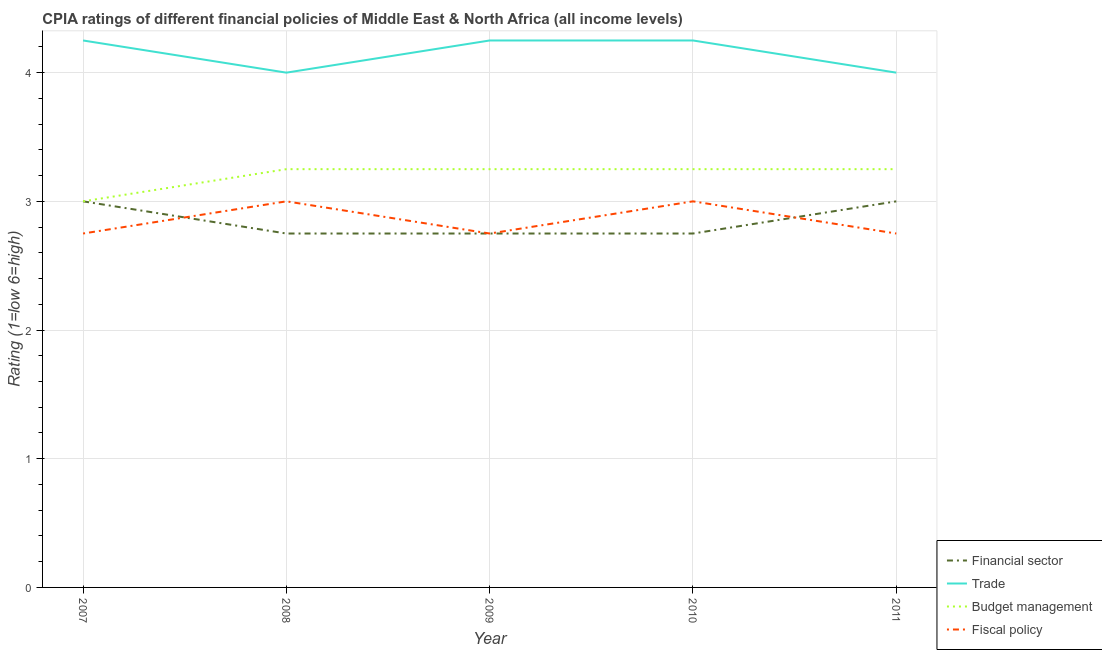How many different coloured lines are there?
Offer a terse response. 4. Is the number of lines equal to the number of legend labels?
Keep it short and to the point. Yes. What is the cpia rating of financial sector in 2011?
Keep it short and to the point. 3. Across all years, what is the maximum cpia rating of trade?
Offer a terse response. 4.25. What is the total cpia rating of financial sector in the graph?
Keep it short and to the point. 14.25. What is the average cpia rating of financial sector per year?
Ensure brevity in your answer.  2.85. In the year 2008, what is the difference between the cpia rating of fiscal policy and cpia rating of financial sector?
Your response must be concise. 0.25. What is the ratio of the cpia rating of fiscal policy in 2008 to that in 2010?
Keep it short and to the point. 1. Is the difference between the cpia rating of budget management in 2009 and 2011 greater than the difference between the cpia rating of trade in 2009 and 2011?
Give a very brief answer. No. In how many years, is the cpia rating of financial sector greater than the average cpia rating of financial sector taken over all years?
Give a very brief answer. 2. Is it the case that in every year, the sum of the cpia rating of financial sector and cpia rating of trade is greater than the cpia rating of budget management?
Give a very brief answer. Yes. Does the cpia rating of budget management monotonically increase over the years?
Provide a short and direct response. No. Is the cpia rating of trade strictly greater than the cpia rating of fiscal policy over the years?
Offer a very short reply. Yes. Does the graph contain any zero values?
Your response must be concise. No. Does the graph contain grids?
Your answer should be compact. Yes. Where does the legend appear in the graph?
Provide a short and direct response. Bottom right. How many legend labels are there?
Offer a terse response. 4. How are the legend labels stacked?
Your response must be concise. Vertical. What is the title of the graph?
Offer a terse response. CPIA ratings of different financial policies of Middle East & North Africa (all income levels). What is the label or title of the Y-axis?
Offer a terse response. Rating (1=low 6=high). What is the Rating (1=low 6=high) of Trade in 2007?
Provide a succinct answer. 4.25. What is the Rating (1=low 6=high) in Budget management in 2007?
Offer a terse response. 3. What is the Rating (1=low 6=high) in Fiscal policy in 2007?
Your answer should be compact. 2.75. What is the Rating (1=low 6=high) in Financial sector in 2008?
Give a very brief answer. 2.75. What is the Rating (1=low 6=high) of Financial sector in 2009?
Keep it short and to the point. 2.75. What is the Rating (1=low 6=high) of Trade in 2009?
Provide a short and direct response. 4.25. What is the Rating (1=low 6=high) in Fiscal policy in 2009?
Provide a succinct answer. 2.75. What is the Rating (1=low 6=high) of Financial sector in 2010?
Provide a short and direct response. 2.75. What is the Rating (1=low 6=high) in Trade in 2010?
Offer a terse response. 4.25. What is the Rating (1=low 6=high) of Financial sector in 2011?
Keep it short and to the point. 3. What is the Rating (1=low 6=high) of Trade in 2011?
Keep it short and to the point. 4. What is the Rating (1=low 6=high) in Fiscal policy in 2011?
Ensure brevity in your answer.  2.75. Across all years, what is the maximum Rating (1=low 6=high) in Trade?
Your answer should be compact. 4.25. Across all years, what is the maximum Rating (1=low 6=high) in Budget management?
Provide a short and direct response. 3.25. Across all years, what is the maximum Rating (1=low 6=high) of Fiscal policy?
Give a very brief answer. 3. Across all years, what is the minimum Rating (1=low 6=high) in Financial sector?
Offer a terse response. 2.75. Across all years, what is the minimum Rating (1=low 6=high) in Trade?
Your answer should be very brief. 4. Across all years, what is the minimum Rating (1=low 6=high) in Budget management?
Make the answer very short. 3. Across all years, what is the minimum Rating (1=low 6=high) of Fiscal policy?
Your response must be concise. 2.75. What is the total Rating (1=low 6=high) in Financial sector in the graph?
Your answer should be very brief. 14.25. What is the total Rating (1=low 6=high) in Trade in the graph?
Your answer should be compact. 20.75. What is the total Rating (1=low 6=high) in Budget management in the graph?
Provide a short and direct response. 16. What is the total Rating (1=low 6=high) of Fiscal policy in the graph?
Provide a succinct answer. 14.25. What is the difference between the Rating (1=low 6=high) of Budget management in 2007 and that in 2008?
Your response must be concise. -0.25. What is the difference between the Rating (1=low 6=high) in Fiscal policy in 2007 and that in 2008?
Offer a very short reply. -0.25. What is the difference between the Rating (1=low 6=high) in Trade in 2007 and that in 2009?
Your answer should be compact. 0. What is the difference between the Rating (1=low 6=high) in Budget management in 2007 and that in 2009?
Your response must be concise. -0.25. What is the difference between the Rating (1=low 6=high) of Budget management in 2007 and that in 2010?
Your answer should be very brief. -0.25. What is the difference between the Rating (1=low 6=high) of Financial sector in 2007 and that in 2011?
Make the answer very short. 0. What is the difference between the Rating (1=low 6=high) of Trade in 2007 and that in 2011?
Give a very brief answer. 0.25. What is the difference between the Rating (1=low 6=high) of Budget management in 2007 and that in 2011?
Give a very brief answer. -0.25. What is the difference between the Rating (1=low 6=high) of Fiscal policy in 2007 and that in 2011?
Your answer should be compact. 0. What is the difference between the Rating (1=low 6=high) of Financial sector in 2008 and that in 2009?
Your response must be concise. 0. What is the difference between the Rating (1=low 6=high) of Fiscal policy in 2008 and that in 2009?
Provide a short and direct response. 0.25. What is the difference between the Rating (1=low 6=high) of Financial sector in 2009 and that in 2010?
Keep it short and to the point. 0. What is the difference between the Rating (1=low 6=high) in Trade in 2009 and that in 2010?
Offer a very short reply. 0. What is the difference between the Rating (1=low 6=high) of Fiscal policy in 2009 and that in 2010?
Provide a succinct answer. -0.25. What is the difference between the Rating (1=low 6=high) in Trade in 2009 and that in 2011?
Offer a very short reply. 0.25. What is the difference between the Rating (1=low 6=high) in Budget management in 2009 and that in 2011?
Your response must be concise. 0. What is the difference between the Rating (1=low 6=high) in Fiscal policy in 2009 and that in 2011?
Your response must be concise. 0. What is the difference between the Rating (1=low 6=high) of Fiscal policy in 2010 and that in 2011?
Offer a terse response. 0.25. What is the difference between the Rating (1=low 6=high) of Financial sector in 2007 and the Rating (1=low 6=high) of Budget management in 2008?
Give a very brief answer. -0.25. What is the difference between the Rating (1=low 6=high) of Financial sector in 2007 and the Rating (1=low 6=high) of Fiscal policy in 2008?
Your response must be concise. 0. What is the difference between the Rating (1=low 6=high) of Financial sector in 2007 and the Rating (1=low 6=high) of Trade in 2009?
Your answer should be very brief. -1.25. What is the difference between the Rating (1=low 6=high) in Financial sector in 2007 and the Rating (1=low 6=high) in Budget management in 2009?
Make the answer very short. -0.25. What is the difference between the Rating (1=low 6=high) of Trade in 2007 and the Rating (1=low 6=high) of Fiscal policy in 2009?
Your response must be concise. 1.5. What is the difference between the Rating (1=low 6=high) in Budget management in 2007 and the Rating (1=low 6=high) in Fiscal policy in 2009?
Your response must be concise. 0.25. What is the difference between the Rating (1=low 6=high) of Financial sector in 2007 and the Rating (1=low 6=high) of Trade in 2010?
Make the answer very short. -1.25. What is the difference between the Rating (1=low 6=high) in Financial sector in 2007 and the Rating (1=low 6=high) in Fiscal policy in 2010?
Your response must be concise. 0. What is the difference between the Rating (1=low 6=high) in Trade in 2007 and the Rating (1=low 6=high) in Budget management in 2010?
Give a very brief answer. 1. What is the difference between the Rating (1=low 6=high) in Financial sector in 2007 and the Rating (1=low 6=high) in Budget management in 2011?
Make the answer very short. -0.25. What is the difference between the Rating (1=low 6=high) of Financial sector in 2007 and the Rating (1=low 6=high) of Fiscal policy in 2011?
Provide a succinct answer. 0.25. What is the difference between the Rating (1=low 6=high) of Trade in 2007 and the Rating (1=low 6=high) of Fiscal policy in 2011?
Give a very brief answer. 1.5. What is the difference between the Rating (1=low 6=high) of Financial sector in 2008 and the Rating (1=low 6=high) of Trade in 2009?
Your answer should be compact. -1.5. What is the difference between the Rating (1=low 6=high) of Financial sector in 2008 and the Rating (1=low 6=high) of Fiscal policy in 2009?
Ensure brevity in your answer.  0. What is the difference between the Rating (1=low 6=high) in Trade in 2008 and the Rating (1=low 6=high) in Fiscal policy in 2009?
Offer a terse response. 1.25. What is the difference between the Rating (1=low 6=high) in Financial sector in 2008 and the Rating (1=low 6=high) in Fiscal policy in 2010?
Your answer should be compact. -0.25. What is the difference between the Rating (1=low 6=high) of Trade in 2008 and the Rating (1=low 6=high) of Fiscal policy in 2010?
Provide a succinct answer. 1. What is the difference between the Rating (1=low 6=high) in Budget management in 2008 and the Rating (1=low 6=high) in Fiscal policy in 2010?
Offer a terse response. 0.25. What is the difference between the Rating (1=low 6=high) in Financial sector in 2008 and the Rating (1=low 6=high) in Trade in 2011?
Give a very brief answer. -1.25. What is the difference between the Rating (1=low 6=high) in Trade in 2008 and the Rating (1=low 6=high) in Fiscal policy in 2011?
Offer a terse response. 1.25. What is the difference between the Rating (1=low 6=high) of Budget management in 2008 and the Rating (1=low 6=high) of Fiscal policy in 2011?
Give a very brief answer. 0.5. What is the difference between the Rating (1=low 6=high) of Financial sector in 2009 and the Rating (1=low 6=high) of Budget management in 2010?
Give a very brief answer. -0.5. What is the difference between the Rating (1=low 6=high) of Financial sector in 2009 and the Rating (1=low 6=high) of Fiscal policy in 2010?
Offer a terse response. -0.25. What is the difference between the Rating (1=low 6=high) in Trade in 2009 and the Rating (1=low 6=high) in Fiscal policy in 2010?
Your answer should be very brief. 1.25. What is the difference between the Rating (1=low 6=high) of Financial sector in 2009 and the Rating (1=low 6=high) of Trade in 2011?
Give a very brief answer. -1.25. What is the difference between the Rating (1=low 6=high) in Financial sector in 2009 and the Rating (1=low 6=high) in Budget management in 2011?
Ensure brevity in your answer.  -0.5. What is the difference between the Rating (1=low 6=high) of Trade in 2009 and the Rating (1=low 6=high) of Budget management in 2011?
Your response must be concise. 1. What is the difference between the Rating (1=low 6=high) in Trade in 2009 and the Rating (1=low 6=high) in Fiscal policy in 2011?
Offer a terse response. 1.5. What is the difference between the Rating (1=low 6=high) of Budget management in 2009 and the Rating (1=low 6=high) of Fiscal policy in 2011?
Your response must be concise. 0.5. What is the difference between the Rating (1=low 6=high) of Financial sector in 2010 and the Rating (1=low 6=high) of Trade in 2011?
Make the answer very short. -1.25. What is the difference between the Rating (1=low 6=high) of Financial sector in 2010 and the Rating (1=low 6=high) of Fiscal policy in 2011?
Offer a terse response. 0. What is the difference between the Rating (1=low 6=high) of Trade in 2010 and the Rating (1=low 6=high) of Budget management in 2011?
Provide a succinct answer. 1. What is the average Rating (1=low 6=high) in Financial sector per year?
Your answer should be compact. 2.85. What is the average Rating (1=low 6=high) in Trade per year?
Your answer should be compact. 4.15. What is the average Rating (1=low 6=high) of Budget management per year?
Make the answer very short. 3.2. What is the average Rating (1=low 6=high) in Fiscal policy per year?
Provide a short and direct response. 2.85. In the year 2007, what is the difference between the Rating (1=low 6=high) in Financial sector and Rating (1=low 6=high) in Trade?
Your response must be concise. -1.25. In the year 2007, what is the difference between the Rating (1=low 6=high) of Trade and Rating (1=low 6=high) of Budget management?
Ensure brevity in your answer.  1.25. In the year 2007, what is the difference between the Rating (1=low 6=high) in Trade and Rating (1=low 6=high) in Fiscal policy?
Ensure brevity in your answer.  1.5. In the year 2008, what is the difference between the Rating (1=low 6=high) of Financial sector and Rating (1=low 6=high) of Trade?
Make the answer very short. -1.25. In the year 2008, what is the difference between the Rating (1=low 6=high) in Trade and Rating (1=low 6=high) in Budget management?
Make the answer very short. 0.75. In the year 2008, what is the difference between the Rating (1=low 6=high) of Trade and Rating (1=low 6=high) of Fiscal policy?
Your response must be concise. 1. In the year 2008, what is the difference between the Rating (1=low 6=high) in Budget management and Rating (1=low 6=high) in Fiscal policy?
Ensure brevity in your answer.  0.25. In the year 2009, what is the difference between the Rating (1=low 6=high) in Financial sector and Rating (1=low 6=high) in Trade?
Provide a short and direct response. -1.5. In the year 2009, what is the difference between the Rating (1=low 6=high) in Financial sector and Rating (1=low 6=high) in Budget management?
Give a very brief answer. -0.5. In the year 2009, what is the difference between the Rating (1=low 6=high) of Trade and Rating (1=low 6=high) of Budget management?
Your response must be concise. 1. In the year 2010, what is the difference between the Rating (1=low 6=high) of Financial sector and Rating (1=low 6=high) of Trade?
Ensure brevity in your answer.  -1.5. In the year 2010, what is the difference between the Rating (1=low 6=high) in Trade and Rating (1=low 6=high) in Budget management?
Offer a very short reply. 1. In the year 2010, what is the difference between the Rating (1=low 6=high) in Trade and Rating (1=low 6=high) in Fiscal policy?
Your response must be concise. 1.25. In the year 2011, what is the difference between the Rating (1=low 6=high) of Financial sector and Rating (1=low 6=high) of Budget management?
Your answer should be very brief. -0.25. In the year 2011, what is the difference between the Rating (1=low 6=high) in Financial sector and Rating (1=low 6=high) in Fiscal policy?
Offer a terse response. 0.25. In the year 2011, what is the difference between the Rating (1=low 6=high) in Trade and Rating (1=low 6=high) in Budget management?
Offer a very short reply. 0.75. In the year 2011, what is the difference between the Rating (1=low 6=high) of Trade and Rating (1=low 6=high) of Fiscal policy?
Offer a terse response. 1.25. In the year 2011, what is the difference between the Rating (1=low 6=high) in Budget management and Rating (1=low 6=high) in Fiscal policy?
Your answer should be very brief. 0.5. What is the ratio of the Rating (1=low 6=high) of Financial sector in 2007 to that in 2008?
Provide a succinct answer. 1.09. What is the ratio of the Rating (1=low 6=high) of Trade in 2007 to that in 2008?
Make the answer very short. 1.06. What is the ratio of the Rating (1=low 6=high) in Fiscal policy in 2007 to that in 2008?
Your answer should be very brief. 0.92. What is the ratio of the Rating (1=low 6=high) of Financial sector in 2007 to that in 2009?
Your response must be concise. 1.09. What is the ratio of the Rating (1=low 6=high) of Fiscal policy in 2007 to that in 2009?
Keep it short and to the point. 1. What is the ratio of the Rating (1=low 6=high) in Budget management in 2007 to that in 2010?
Your answer should be very brief. 0.92. What is the ratio of the Rating (1=low 6=high) of Financial sector in 2007 to that in 2011?
Offer a terse response. 1. What is the ratio of the Rating (1=low 6=high) of Trade in 2007 to that in 2011?
Keep it short and to the point. 1.06. What is the ratio of the Rating (1=low 6=high) in Budget management in 2007 to that in 2011?
Offer a very short reply. 0.92. What is the ratio of the Rating (1=low 6=high) of Trade in 2008 to that in 2009?
Make the answer very short. 0.94. What is the ratio of the Rating (1=low 6=high) of Fiscal policy in 2008 to that in 2009?
Provide a succinct answer. 1.09. What is the ratio of the Rating (1=low 6=high) in Financial sector in 2008 to that in 2010?
Your response must be concise. 1. What is the ratio of the Rating (1=low 6=high) in Trade in 2008 to that in 2011?
Provide a short and direct response. 1. What is the ratio of the Rating (1=low 6=high) of Financial sector in 2009 to that in 2010?
Give a very brief answer. 1. What is the ratio of the Rating (1=low 6=high) of Budget management in 2009 to that in 2010?
Make the answer very short. 1. What is the ratio of the Rating (1=low 6=high) of Fiscal policy in 2009 to that in 2010?
Provide a short and direct response. 0.92. What is the ratio of the Rating (1=low 6=high) in Financial sector in 2009 to that in 2011?
Your answer should be compact. 0.92. What is the ratio of the Rating (1=low 6=high) of Fiscal policy in 2009 to that in 2011?
Your answer should be compact. 1. What is the ratio of the Rating (1=low 6=high) of Fiscal policy in 2010 to that in 2011?
Your answer should be compact. 1.09. What is the difference between the highest and the second highest Rating (1=low 6=high) in Financial sector?
Your response must be concise. 0. What is the difference between the highest and the second highest Rating (1=low 6=high) of Trade?
Ensure brevity in your answer.  0. What is the difference between the highest and the second highest Rating (1=low 6=high) in Fiscal policy?
Offer a very short reply. 0. What is the difference between the highest and the lowest Rating (1=low 6=high) in Financial sector?
Provide a short and direct response. 0.25. What is the difference between the highest and the lowest Rating (1=low 6=high) in Fiscal policy?
Give a very brief answer. 0.25. 